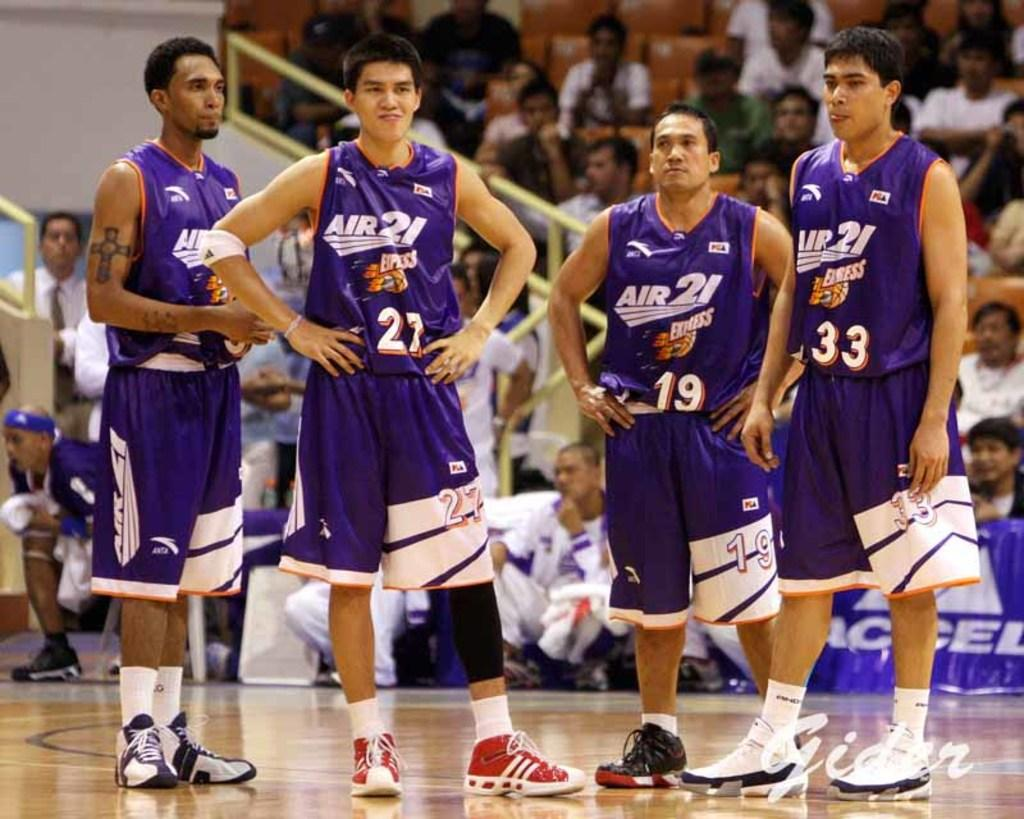<image>
Share a concise interpretation of the image provided. Several players in purple Air 21 Express uniforms stand around on the basketball court. 